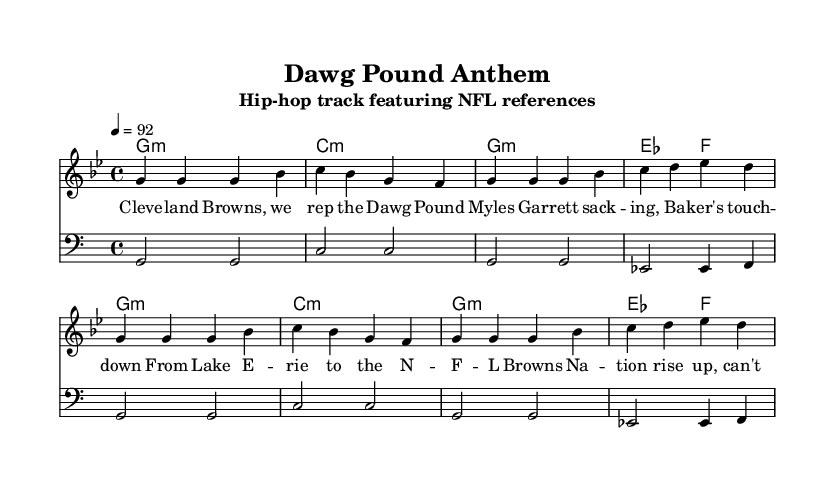What is the key signature of this music? The key signature is indicated by the sharp or flat symbols in the key signature section at the beginning of the sheet music. In this case, it is G minor, which has two flats.
Answer: G minor What is the time signature of this music? The time signature is found near the beginning of the score, indicating how many beats are in each measure. Here, it is 4/4, which means there are four beats in each measure.
Answer: 4/4 What is the tempo of this music? The tempo is usually indicated above the staff and is expressed in beats per minute (BPM). In this sheet, the tempo marking is 4 = 92, meaning there are 92 beats per minute.
Answer: 92 How many measures are in the melody? To determine the number of measures, one can count the groups of notes separated by bar lines in the melody section. There are eight measures in the melody.
Answer: 8 What is the name of the song represented by this sheet music? The title of the song is listed in the header at the top of the sheet music, under "title". It is "Dawg Pound Anthem".
Answer: Dawg Pound Anthem What NFL team is referenced in the lyrics of this music? The lyrics mention "Cleveland Browns," which indicates the NFL team being referenced in this song. This can be found in the first line of the lyrics.
Answer: Cleveland Browns Who is mentioned in the lyrics as a player? The lyrics contain a reference to "Myles Garrett," a player known for playing for the Cleveland Browns. This is found specifically in the second line of the lyrics.
Answer: Myles Garrett 